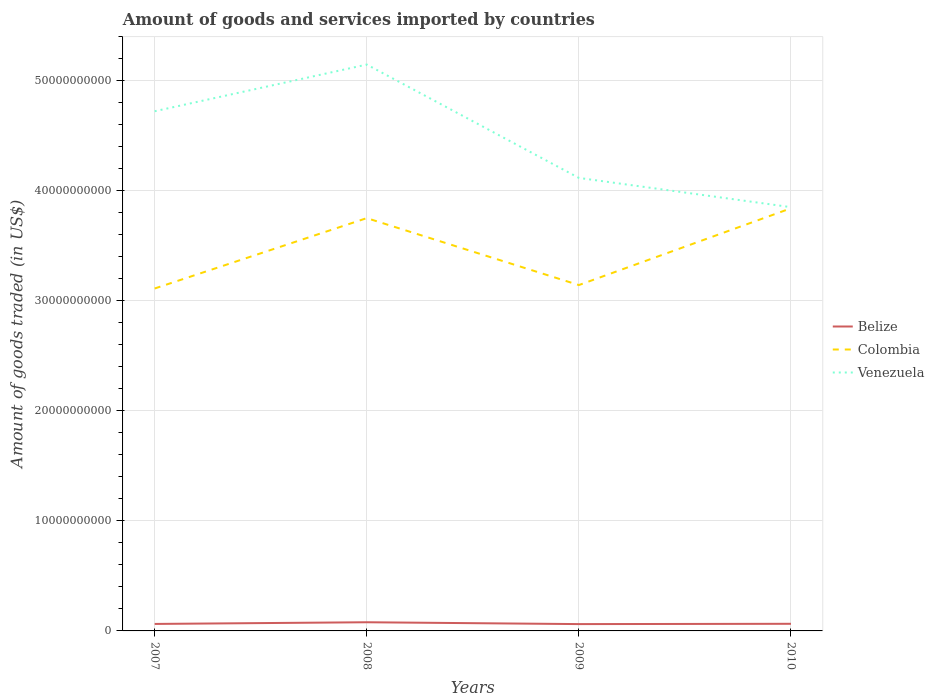Is the number of lines equal to the number of legend labels?
Provide a succinct answer. Yes. Across all years, what is the maximum total amount of goods and services imported in Venezuela?
Keep it short and to the point. 3.85e+1. What is the total total amount of goods and services imported in Belize in the graph?
Make the answer very short. 1.68e+08. What is the difference between the highest and the second highest total amount of goods and services imported in Venezuela?
Keep it short and to the point. 1.30e+1. Is the total amount of goods and services imported in Belize strictly greater than the total amount of goods and services imported in Colombia over the years?
Keep it short and to the point. Yes. How many lines are there?
Keep it short and to the point. 3. Are the values on the major ticks of Y-axis written in scientific E-notation?
Keep it short and to the point. No. Does the graph contain any zero values?
Offer a terse response. No. Does the graph contain grids?
Offer a terse response. Yes. Where does the legend appear in the graph?
Provide a short and direct response. Center right. What is the title of the graph?
Ensure brevity in your answer.  Amount of goods and services imported by countries. Does "Norway" appear as one of the legend labels in the graph?
Give a very brief answer. No. What is the label or title of the Y-axis?
Provide a short and direct response. Amount of goods traded (in US$). What is the Amount of goods traded (in US$) in Belize in 2007?
Your answer should be compact. 6.35e+08. What is the Amount of goods traded (in US$) in Colombia in 2007?
Offer a terse response. 3.11e+1. What is the Amount of goods traded (in US$) of Venezuela in 2007?
Make the answer very short. 4.72e+1. What is the Amount of goods traded (in US$) in Belize in 2008?
Give a very brief answer. 7.88e+08. What is the Amount of goods traded (in US$) of Colombia in 2008?
Your answer should be very brief. 3.75e+1. What is the Amount of goods traded (in US$) of Venezuela in 2008?
Make the answer very short. 5.15e+1. What is the Amount of goods traded (in US$) of Belize in 2009?
Provide a succinct answer. 6.21e+08. What is the Amount of goods traded (in US$) of Colombia in 2009?
Keep it short and to the point. 3.14e+1. What is the Amount of goods traded (in US$) of Venezuela in 2009?
Your response must be concise. 4.12e+1. What is the Amount of goods traded (in US$) in Belize in 2010?
Provide a short and direct response. 6.47e+08. What is the Amount of goods traded (in US$) of Colombia in 2010?
Your answer should be very brief. 3.84e+1. What is the Amount of goods traded (in US$) of Venezuela in 2010?
Your answer should be compact. 3.85e+1. Across all years, what is the maximum Amount of goods traded (in US$) in Belize?
Your answer should be compact. 7.88e+08. Across all years, what is the maximum Amount of goods traded (in US$) of Colombia?
Keep it short and to the point. 3.84e+1. Across all years, what is the maximum Amount of goods traded (in US$) in Venezuela?
Provide a short and direct response. 5.15e+1. Across all years, what is the minimum Amount of goods traded (in US$) in Belize?
Offer a terse response. 6.21e+08. Across all years, what is the minimum Amount of goods traded (in US$) in Colombia?
Keep it short and to the point. 3.11e+1. Across all years, what is the minimum Amount of goods traded (in US$) of Venezuela?
Provide a succinct answer. 3.85e+1. What is the total Amount of goods traded (in US$) of Belize in the graph?
Give a very brief answer. 2.69e+09. What is the total Amount of goods traded (in US$) of Colombia in the graph?
Provide a short and direct response. 1.38e+11. What is the total Amount of goods traded (in US$) in Venezuela in the graph?
Make the answer very short. 1.78e+11. What is the difference between the Amount of goods traded (in US$) of Belize in 2007 and that in 2008?
Provide a succinct answer. -1.54e+08. What is the difference between the Amount of goods traded (in US$) of Colombia in 2007 and that in 2008?
Make the answer very short. -6.40e+09. What is the difference between the Amount of goods traded (in US$) in Venezuela in 2007 and that in 2008?
Offer a terse response. -4.24e+09. What is the difference between the Amount of goods traded (in US$) in Belize in 2007 and that in 2009?
Your answer should be compact. 1.42e+07. What is the difference between the Amount of goods traded (in US$) of Colombia in 2007 and that in 2009?
Your answer should be very brief. -3.12e+08. What is the difference between the Amount of goods traded (in US$) in Venezuela in 2007 and that in 2009?
Your answer should be very brief. 6.06e+09. What is the difference between the Amount of goods traded (in US$) in Belize in 2007 and that in 2010?
Make the answer very short. -1.25e+07. What is the difference between the Amount of goods traded (in US$) of Colombia in 2007 and that in 2010?
Keep it short and to the point. -7.29e+09. What is the difference between the Amount of goods traded (in US$) in Venezuela in 2007 and that in 2010?
Make the answer very short. 8.72e+09. What is the difference between the Amount of goods traded (in US$) in Belize in 2008 and that in 2009?
Offer a very short reply. 1.68e+08. What is the difference between the Amount of goods traded (in US$) in Colombia in 2008 and that in 2009?
Provide a short and direct response. 6.08e+09. What is the difference between the Amount of goods traded (in US$) in Venezuela in 2008 and that in 2009?
Your answer should be very brief. 1.03e+1. What is the difference between the Amount of goods traded (in US$) in Belize in 2008 and that in 2010?
Give a very brief answer. 1.41e+08. What is the difference between the Amount of goods traded (in US$) of Colombia in 2008 and that in 2010?
Your answer should be very brief. -8.94e+08. What is the difference between the Amount of goods traded (in US$) of Venezuela in 2008 and that in 2010?
Keep it short and to the point. 1.30e+1. What is the difference between the Amount of goods traded (in US$) in Belize in 2009 and that in 2010?
Your response must be concise. -2.67e+07. What is the difference between the Amount of goods traded (in US$) in Colombia in 2009 and that in 2010?
Your response must be concise. -6.98e+09. What is the difference between the Amount of goods traded (in US$) of Venezuela in 2009 and that in 2010?
Keep it short and to the point. 2.66e+09. What is the difference between the Amount of goods traded (in US$) in Belize in 2007 and the Amount of goods traded (in US$) in Colombia in 2008?
Your answer should be very brief. -3.69e+1. What is the difference between the Amount of goods traded (in US$) of Belize in 2007 and the Amount of goods traded (in US$) of Venezuela in 2008?
Offer a terse response. -5.08e+1. What is the difference between the Amount of goods traded (in US$) of Colombia in 2007 and the Amount of goods traded (in US$) of Venezuela in 2008?
Keep it short and to the point. -2.03e+1. What is the difference between the Amount of goods traded (in US$) in Belize in 2007 and the Amount of goods traded (in US$) in Colombia in 2009?
Your response must be concise. -3.08e+1. What is the difference between the Amount of goods traded (in US$) of Belize in 2007 and the Amount of goods traded (in US$) of Venezuela in 2009?
Your answer should be very brief. -4.05e+1. What is the difference between the Amount of goods traded (in US$) in Colombia in 2007 and the Amount of goods traded (in US$) in Venezuela in 2009?
Keep it short and to the point. -1.00e+1. What is the difference between the Amount of goods traded (in US$) of Belize in 2007 and the Amount of goods traded (in US$) of Colombia in 2010?
Your answer should be compact. -3.78e+1. What is the difference between the Amount of goods traded (in US$) in Belize in 2007 and the Amount of goods traded (in US$) in Venezuela in 2010?
Your response must be concise. -3.79e+1. What is the difference between the Amount of goods traded (in US$) in Colombia in 2007 and the Amount of goods traded (in US$) in Venezuela in 2010?
Ensure brevity in your answer.  -7.39e+09. What is the difference between the Amount of goods traded (in US$) of Belize in 2008 and the Amount of goods traded (in US$) of Colombia in 2009?
Your response must be concise. -3.06e+1. What is the difference between the Amount of goods traded (in US$) in Belize in 2008 and the Amount of goods traded (in US$) in Venezuela in 2009?
Make the answer very short. -4.04e+1. What is the difference between the Amount of goods traded (in US$) of Colombia in 2008 and the Amount of goods traded (in US$) of Venezuela in 2009?
Offer a terse response. -3.65e+09. What is the difference between the Amount of goods traded (in US$) in Belize in 2008 and the Amount of goods traded (in US$) in Colombia in 2010?
Provide a short and direct response. -3.76e+1. What is the difference between the Amount of goods traded (in US$) in Belize in 2008 and the Amount of goods traded (in US$) in Venezuela in 2010?
Give a very brief answer. -3.77e+1. What is the difference between the Amount of goods traded (in US$) of Colombia in 2008 and the Amount of goods traded (in US$) of Venezuela in 2010?
Your answer should be compact. -9.96e+08. What is the difference between the Amount of goods traded (in US$) in Belize in 2009 and the Amount of goods traded (in US$) in Colombia in 2010?
Offer a terse response. -3.78e+1. What is the difference between the Amount of goods traded (in US$) in Belize in 2009 and the Amount of goods traded (in US$) in Venezuela in 2010?
Ensure brevity in your answer.  -3.79e+1. What is the difference between the Amount of goods traded (in US$) in Colombia in 2009 and the Amount of goods traded (in US$) in Venezuela in 2010?
Your response must be concise. -7.08e+09. What is the average Amount of goods traded (in US$) in Belize per year?
Provide a short and direct response. 6.73e+08. What is the average Amount of goods traded (in US$) of Colombia per year?
Your answer should be very brief. 3.46e+1. What is the average Amount of goods traded (in US$) in Venezuela per year?
Provide a short and direct response. 4.46e+1. In the year 2007, what is the difference between the Amount of goods traded (in US$) of Belize and Amount of goods traded (in US$) of Colombia?
Provide a succinct answer. -3.05e+1. In the year 2007, what is the difference between the Amount of goods traded (in US$) of Belize and Amount of goods traded (in US$) of Venezuela?
Provide a succinct answer. -4.66e+1. In the year 2007, what is the difference between the Amount of goods traded (in US$) in Colombia and Amount of goods traded (in US$) in Venezuela?
Offer a very short reply. -1.61e+1. In the year 2008, what is the difference between the Amount of goods traded (in US$) in Belize and Amount of goods traded (in US$) in Colombia?
Your response must be concise. -3.67e+1. In the year 2008, what is the difference between the Amount of goods traded (in US$) of Belize and Amount of goods traded (in US$) of Venezuela?
Your response must be concise. -5.07e+1. In the year 2008, what is the difference between the Amount of goods traded (in US$) of Colombia and Amount of goods traded (in US$) of Venezuela?
Offer a very short reply. -1.40e+1. In the year 2009, what is the difference between the Amount of goods traded (in US$) in Belize and Amount of goods traded (in US$) in Colombia?
Your response must be concise. -3.08e+1. In the year 2009, what is the difference between the Amount of goods traded (in US$) of Belize and Amount of goods traded (in US$) of Venezuela?
Provide a succinct answer. -4.05e+1. In the year 2009, what is the difference between the Amount of goods traded (in US$) in Colombia and Amount of goods traded (in US$) in Venezuela?
Offer a very short reply. -9.74e+09. In the year 2010, what is the difference between the Amount of goods traded (in US$) of Belize and Amount of goods traded (in US$) of Colombia?
Your answer should be very brief. -3.78e+1. In the year 2010, what is the difference between the Amount of goods traded (in US$) of Belize and Amount of goods traded (in US$) of Venezuela?
Keep it short and to the point. -3.79e+1. In the year 2010, what is the difference between the Amount of goods traded (in US$) in Colombia and Amount of goods traded (in US$) in Venezuela?
Provide a short and direct response. -1.01e+08. What is the ratio of the Amount of goods traded (in US$) of Belize in 2007 to that in 2008?
Provide a succinct answer. 0.81. What is the ratio of the Amount of goods traded (in US$) of Colombia in 2007 to that in 2008?
Keep it short and to the point. 0.83. What is the ratio of the Amount of goods traded (in US$) of Venezuela in 2007 to that in 2008?
Offer a terse response. 0.92. What is the ratio of the Amount of goods traded (in US$) in Belize in 2007 to that in 2009?
Your response must be concise. 1.02. What is the ratio of the Amount of goods traded (in US$) in Venezuela in 2007 to that in 2009?
Ensure brevity in your answer.  1.15. What is the ratio of the Amount of goods traded (in US$) of Belize in 2007 to that in 2010?
Offer a very short reply. 0.98. What is the ratio of the Amount of goods traded (in US$) in Colombia in 2007 to that in 2010?
Provide a succinct answer. 0.81. What is the ratio of the Amount of goods traded (in US$) in Venezuela in 2007 to that in 2010?
Your response must be concise. 1.23. What is the ratio of the Amount of goods traded (in US$) in Belize in 2008 to that in 2009?
Give a very brief answer. 1.27. What is the ratio of the Amount of goods traded (in US$) of Colombia in 2008 to that in 2009?
Your answer should be compact. 1.19. What is the ratio of the Amount of goods traded (in US$) in Venezuela in 2008 to that in 2009?
Make the answer very short. 1.25. What is the ratio of the Amount of goods traded (in US$) in Belize in 2008 to that in 2010?
Ensure brevity in your answer.  1.22. What is the ratio of the Amount of goods traded (in US$) of Colombia in 2008 to that in 2010?
Make the answer very short. 0.98. What is the ratio of the Amount of goods traded (in US$) of Venezuela in 2008 to that in 2010?
Offer a very short reply. 1.34. What is the ratio of the Amount of goods traded (in US$) in Belize in 2009 to that in 2010?
Your answer should be very brief. 0.96. What is the ratio of the Amount of goods traded (in US$) in Colombia in 2009 to that in 2010?
Provide a short and direct response. 0.82. What is the ratio of the Amount of goods traded (in US$) of Venezuela in 2009 to that in 2010?
Make the answer very short. 1.07. What is the difference between the highest and the second highest Amount of goods traded (in US$) of Belize?
Provide a succinct answer. 1.41e+08. What is the difference between the highest and the second highest Amount of goods traded (in US$) in Colombia?
Your response must be concise. 8.94e+08. What is the difference between the highest and the second highest Amount of goods traded (in US$) in Venezuela?
Your answer should be compact. 4.24e+09. What is the difference between the highest and the lowest Amount of goods traded (in US$) of Belize?
Provide a succinct answer. 1.68e+08. What is the difference between the highest and the lowest Amount of goods traded (in US$) of Colombia?
Make the answer very short. 7.29e+09. What is the difference between the highest and the lowest Amount of goods traded (in US$) of Venezuela?
Keep it short and to the point. 1.30e+1. 